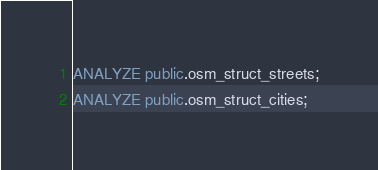Convert code to text. <code><loc_0><loc_0><loc_500><loc_500><_SQL_>ANALYZE public.osm_struct_streets;
ANALYZE public.osm_struct_cities;</code> 